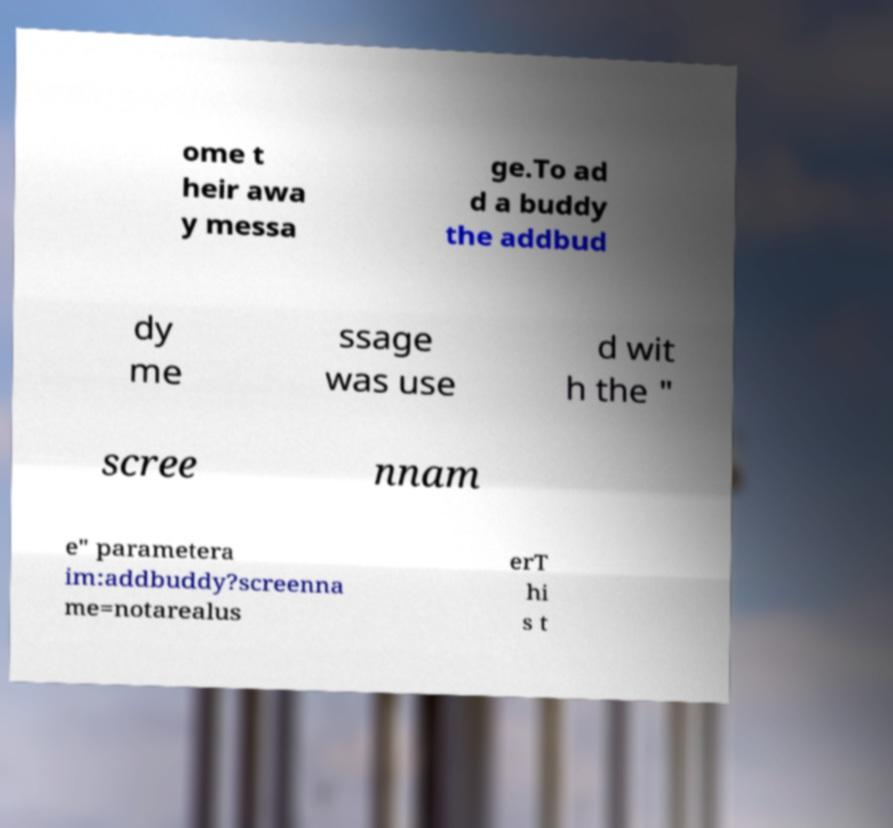Can you read and provide the text displayed in the image?This photo seems to have some interesting text. Can you extract and type it out for me? ome t heir awa y messa ge.To ad d a buddy the addbud dy me ssage was use d wit h the " scree nnam e" parametera im:addbuddy?screenna me=notarealus erT hi s t 